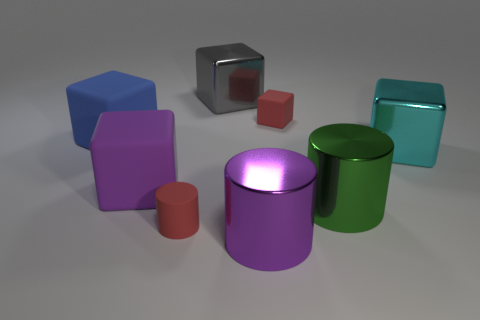The purple thing behind the big purple metal cylinder that is in front of the big shiny object that is on the right side of the big green metal thing is made of what material?
Provide a succinct answer. Rubber. Are there any other things that are the same shape as the gray metal thing?
Offer a very short reply. Yes. There is another big rubber object that is the same shape as the purple matte object; what color is it?
Offer a terse response. Blue. There is a cube that is to the right of the big green thing; does it have the same color as the large object that is behind the red cube?
Make the answer very short. No. Is the number of big blue matte things that are in front of the tiny red cylinder greater than the number of large blue objects?
Provide a succinct answer. No. How many other objects are the same size as the purple rubber cube?
Keep it short and to the point. 5. What number of things are both on the right side of the red cylinder and in front of the green object?
Offer a terse response. 1. Are the large gray block that is to the left of the big cyan metallic object and the green cylinder made of the same material?
Keep it short and to the point. Yes. There is a red thing that is to the left of the big thing that is in front of the red rubber object in front of the green metal thing; what is its shape?
Your answer should be compact. Cylinder. Are there the same number of big gray metallic cubes in front of the large green object and large green shiny things behind the large purple rubber thing?
Provide a short and direct response. Yes. 